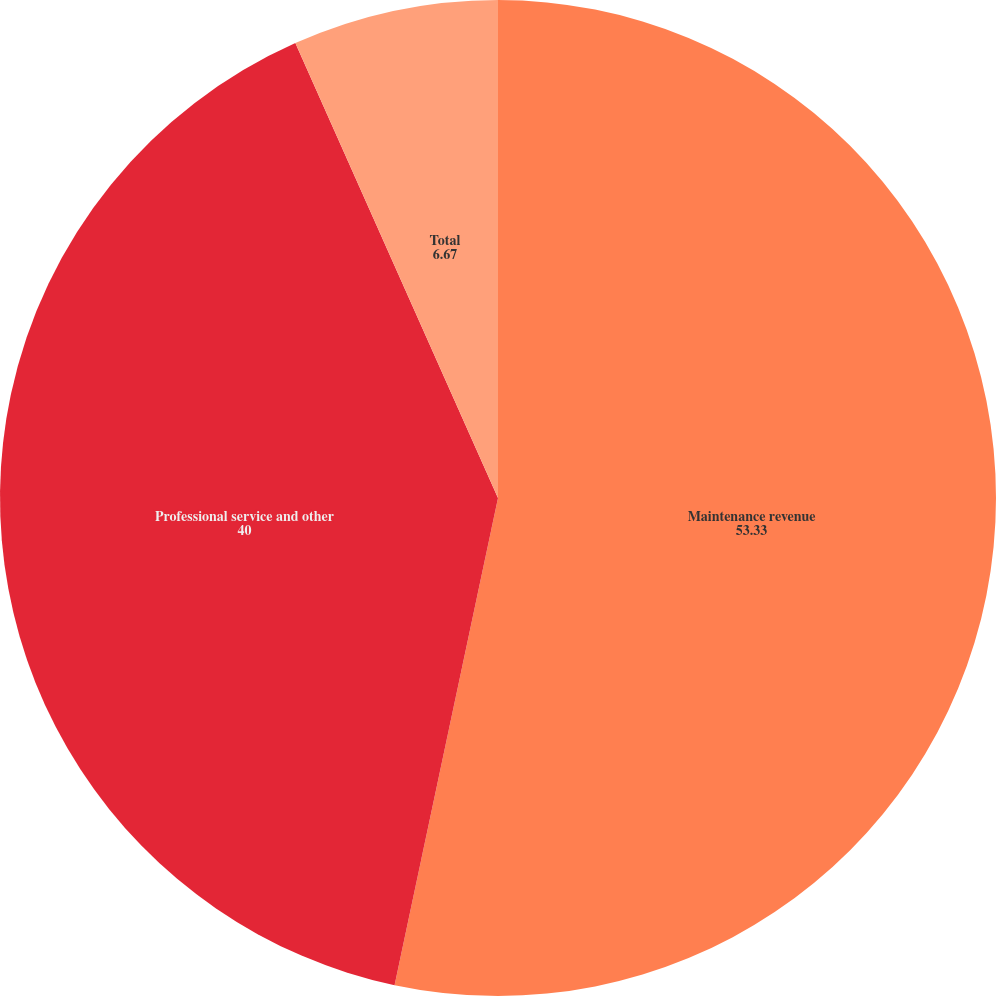<chart> <loc_0><loc_0><loc_500><loc_500><pie_chart><fcel>Maintenance revenue<fcel>Professional service and other<fcel>Total<nl><fcel>53.33%<fcel>40.0%<fcel>6.67%<nl></chart> 